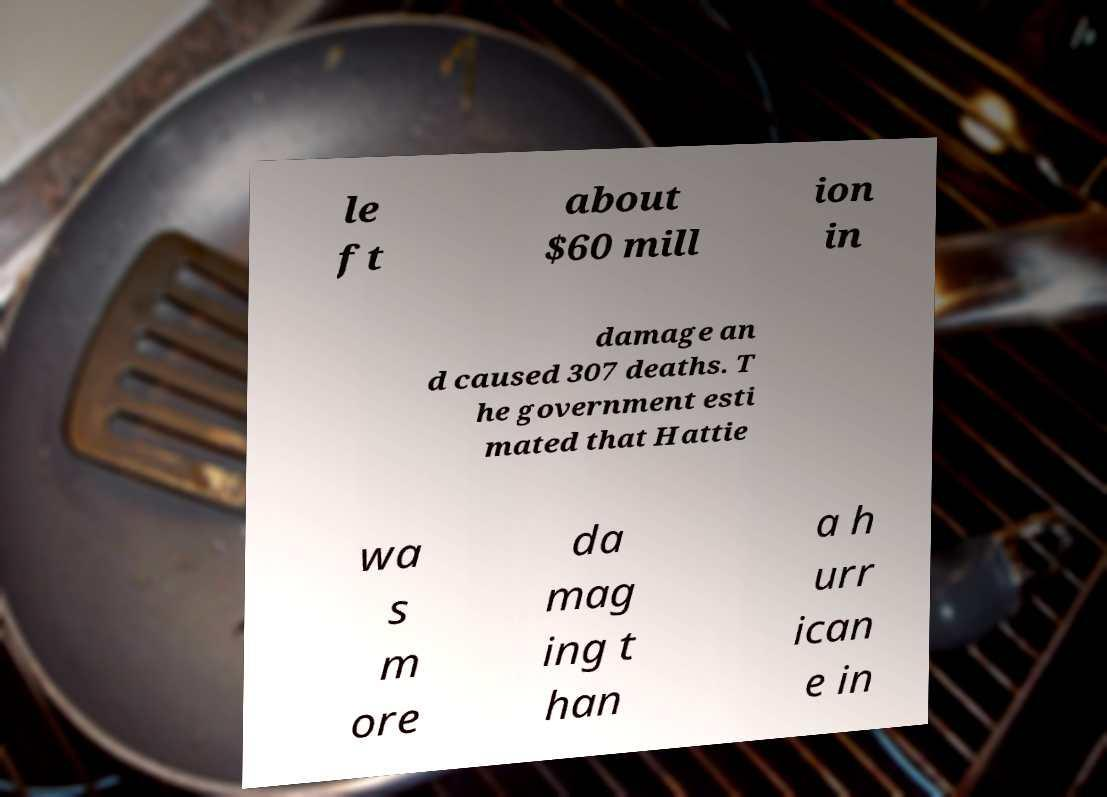I need the written content from this picture converted into text. Can you do that? le ft about $60 mill ion in damage an d caused 307 deaths. T he government esti mated that Hattie wa s m ore da mag ing t han a h urr ican e in 